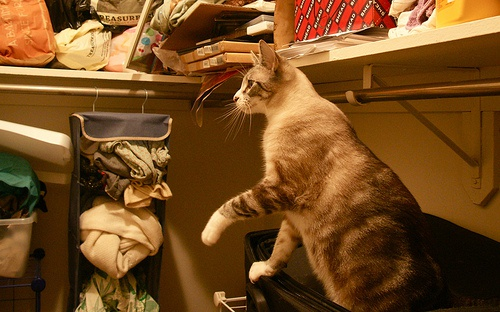Describe the objects in this image and their specific colors. I can see cat in orange, brown, maroon, black, and tan tones, suitcase in orange, black, maroon, and brown tones, and book in orange and red tones in this image. 